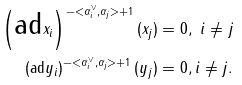<formula> <loc_0><loc_0><loc_500><loc_500>\left ( \text {ad} x _ { i } \right ) ^ { - < \alpha _ { i } ^ { \vee } , \alpha _ { j } > + 1 } ( x _ { j } ) & = 0 , \text { } i \neq j \\ \left ( \text {ad} y _ { i } \right ) ^ { - < \alpha _ { i } ^ { \vee } , \alpha _ { j } > + 1 } ( y _ { j } ) & = 0 , i \neq j .</formula> 